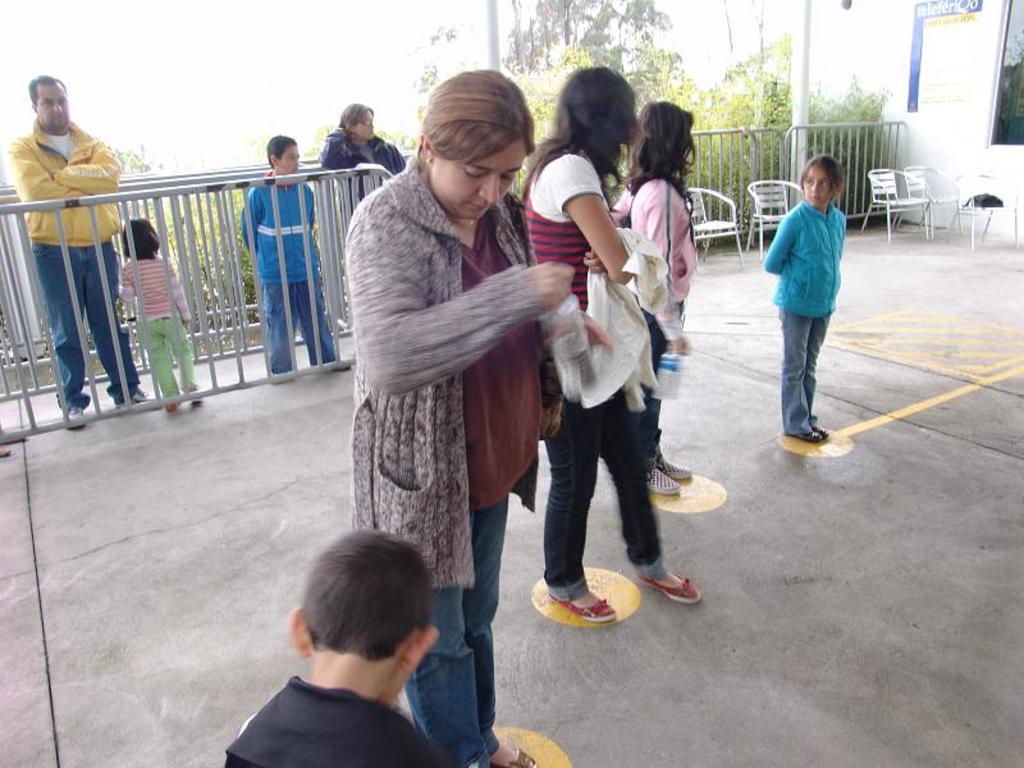How many people are in the image? There are people in the image, but the exact number is not specified. What can be seen in the image that might be used for support or safety? There are railings and poles in the image that can be used for support or safety. What type of furniture is present in the image? There are chairs in the image. What is the purpose of the board in the image? The purpose of the board in the image is not specified, but it could be used for displaying information or as a surface for writing or drawing. What is the wall in the image made of? The material of the wall in the image is not specified. What can be seen through the window in the image? The view through the window in the image is not specified. What type of vegetation is visible in the image? There are trees in the image. What are the two people holding in the image? Two people are holding bottles in the image. Who is the owner of the knot in the image? There is no knot present in the image, so it is not possible to determine the owner. 